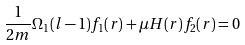<formula> <loc_0><loc_0><loc_500><loc_500>\frac { 1 } { 2 m } \Omega _ { 1 } ( l - 1 ) f _ { 1 } ( r ) + \mu H ( r ) f _ { 2 } ( r ) = 0</formula> 